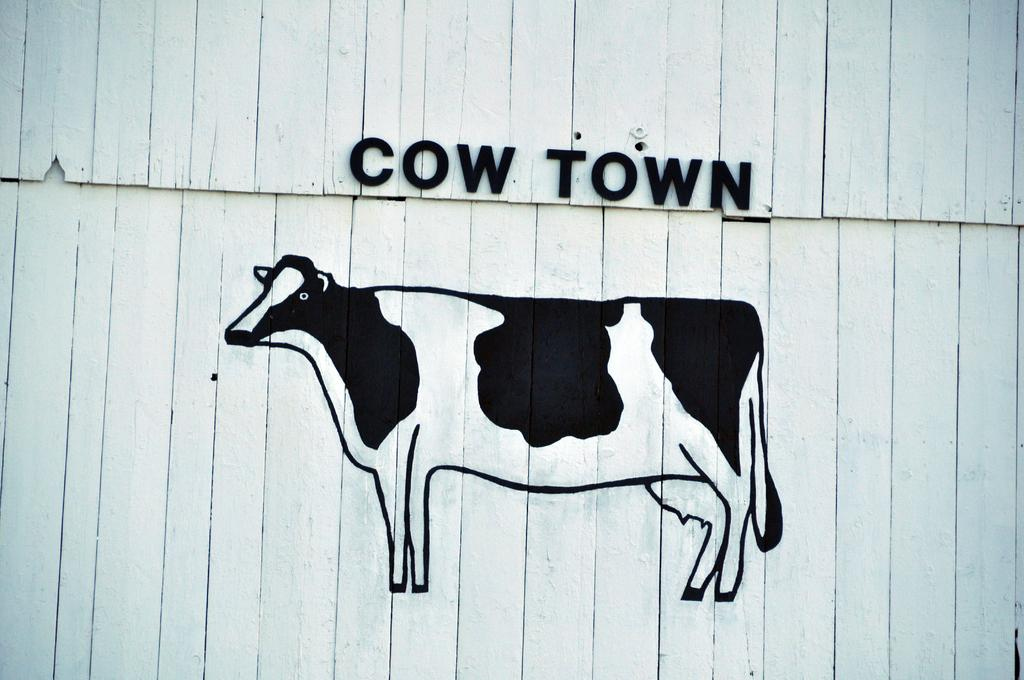What is present on the wall in the image? There is a painting of a cow on the wall. What is depicted in the painting? The painting features a cow. Is there any text present on the painting? Yes, there is text written on the painting. What type of shoe can be seen in the painting? There is no shoe present in the painting; it features a cow and text. Can you tell me which vein is depicted in the painting? There are no veins depicted in the painting; it features a cow and text. 